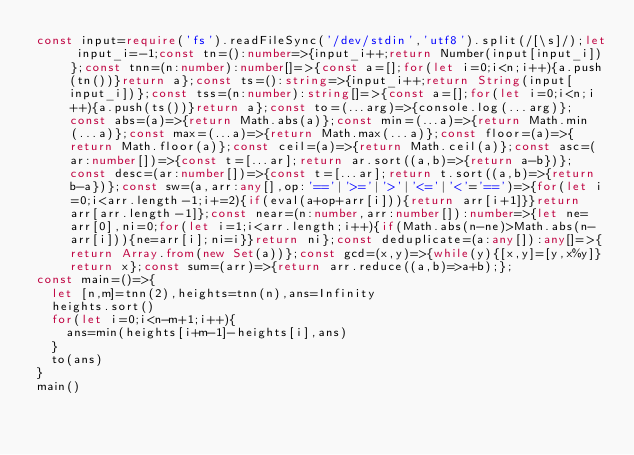<code> <loc_0><loc_0><loc_500><loc_500><_TypeScript_>const input=require('fs').readFileSync('/dev/stdin','utf8').split(/[\s]/);let input_i=-1;const tn=():number=>{input_i++;return Number(input[input_i])};const tnn=(n:number):number[]=>{const a=[];for(let i=0;i<n;i++){a.push(tn())}return a};const ts=():string=>{input_i++;return String(input[input_i])};const tss=(n:number):string[]=>{const a=[];for(let i=0;i<n;i++){a.push(ts())}return a};const to=(...arg)=>{console.log(...arg)};const abs=(a)=>{return Math.abs(a)};const min=(...a)=>{return Math.min(...a)};const max=(...a)=>{return Math.max(...a)};const floor=(a)=>{return Math.floor(a)};const ceil=(a)=>{return Math.ceil(a)};const asc=(ar:number[])=>{const t=[...ar];return ar.sort((a,b)=>{return a-b})};const desc=(ar:number[])=>{const t=[...ar];return t.sort((a,b)=>{return b-a})};const sw=(a,arr:any[],op:'=='|'>='|'>'|'<='|'<'='==')=>{for(let i=0;i<arr.length-1;i+=2){if(eval(a+op+arr[i])){return arr[i+1]}}return arr[arr.length-1]};const near=(n:number,arr:number[]):number=>{let ne=arr[0],ni=0;for(let i=1;i<arr.length;i++){if(Math.abs(n-ne)>Math.abs(n-arr[i])){ne=arr[i];ni=i}}return ni};const deduplicate=(a:any[]):any[]=>{return Array.from(new Set(a))};const gcd=(x,y)=>{while(y){[x,y]=[y,x%y]}return x};const sum=(arr)=>{return arr.reduce((a,b)=>a+b);};
const main=()=>{
  let [n,m]=tnn(2),heights=tnn(n),ans=Infinity
  heights.sort()
  for(let i=0;i<n-m+1;i++){
    ans=min(heights[i+m-1]-heights[i],ans)
  }
  to(ans)
}
main()
</code> 